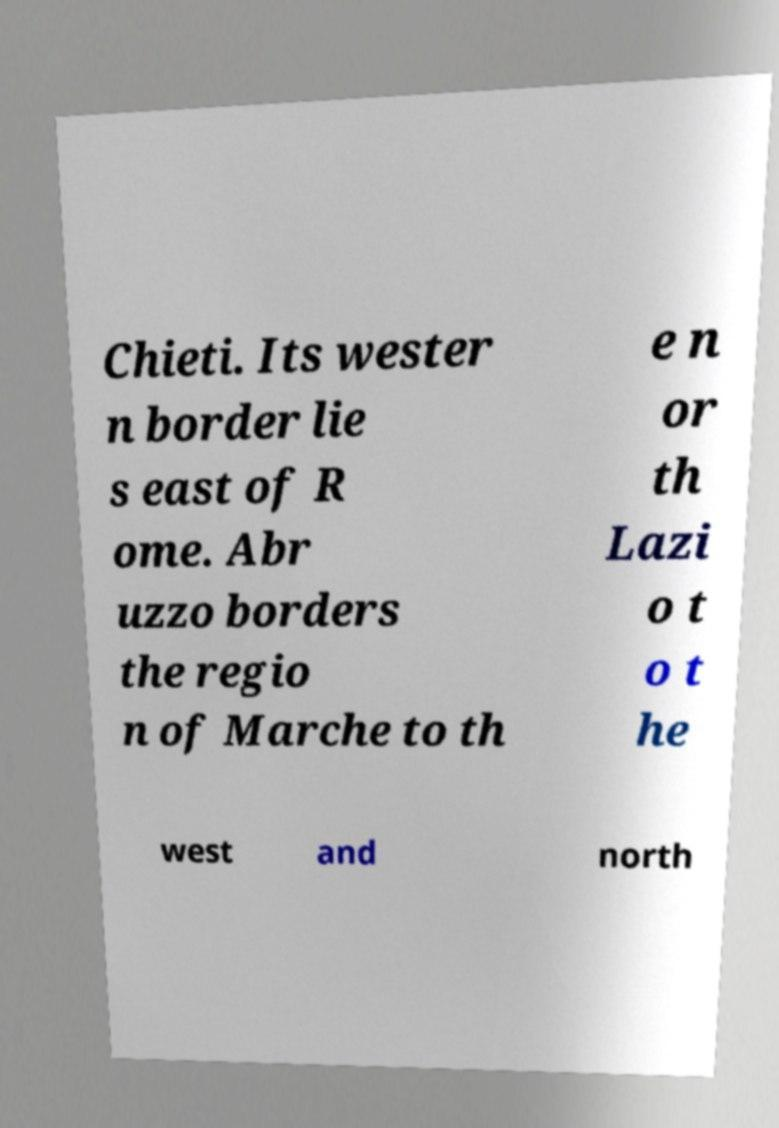Please read and relay the text visible in this image. What does it say? Chieti. Its wester n border lie s east of R ome. Abr uzzo borders the regio n of Marche to th e n or th Lazi o t o t he west and north 